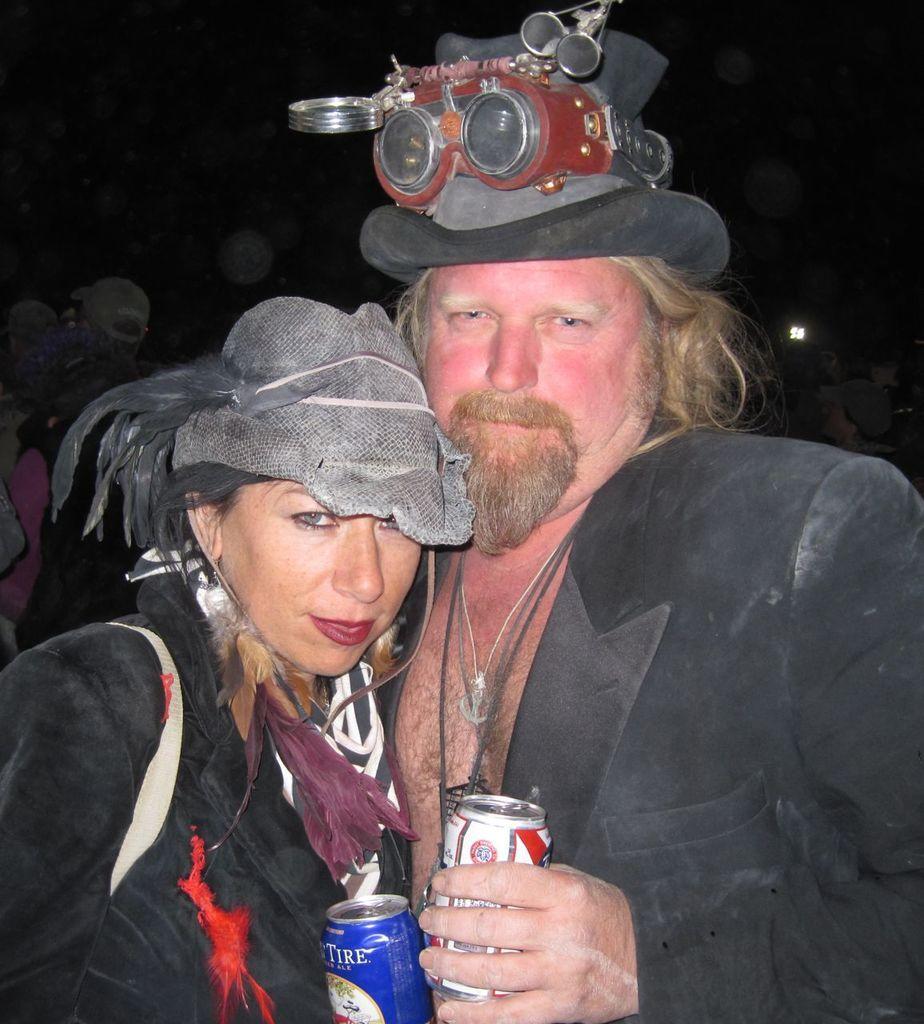In one or two sentences, can you explain what this image depicts? In this image we can see two persons wearing black color dress and also wearing hats, holding coke tins in their hands hugging each other. 